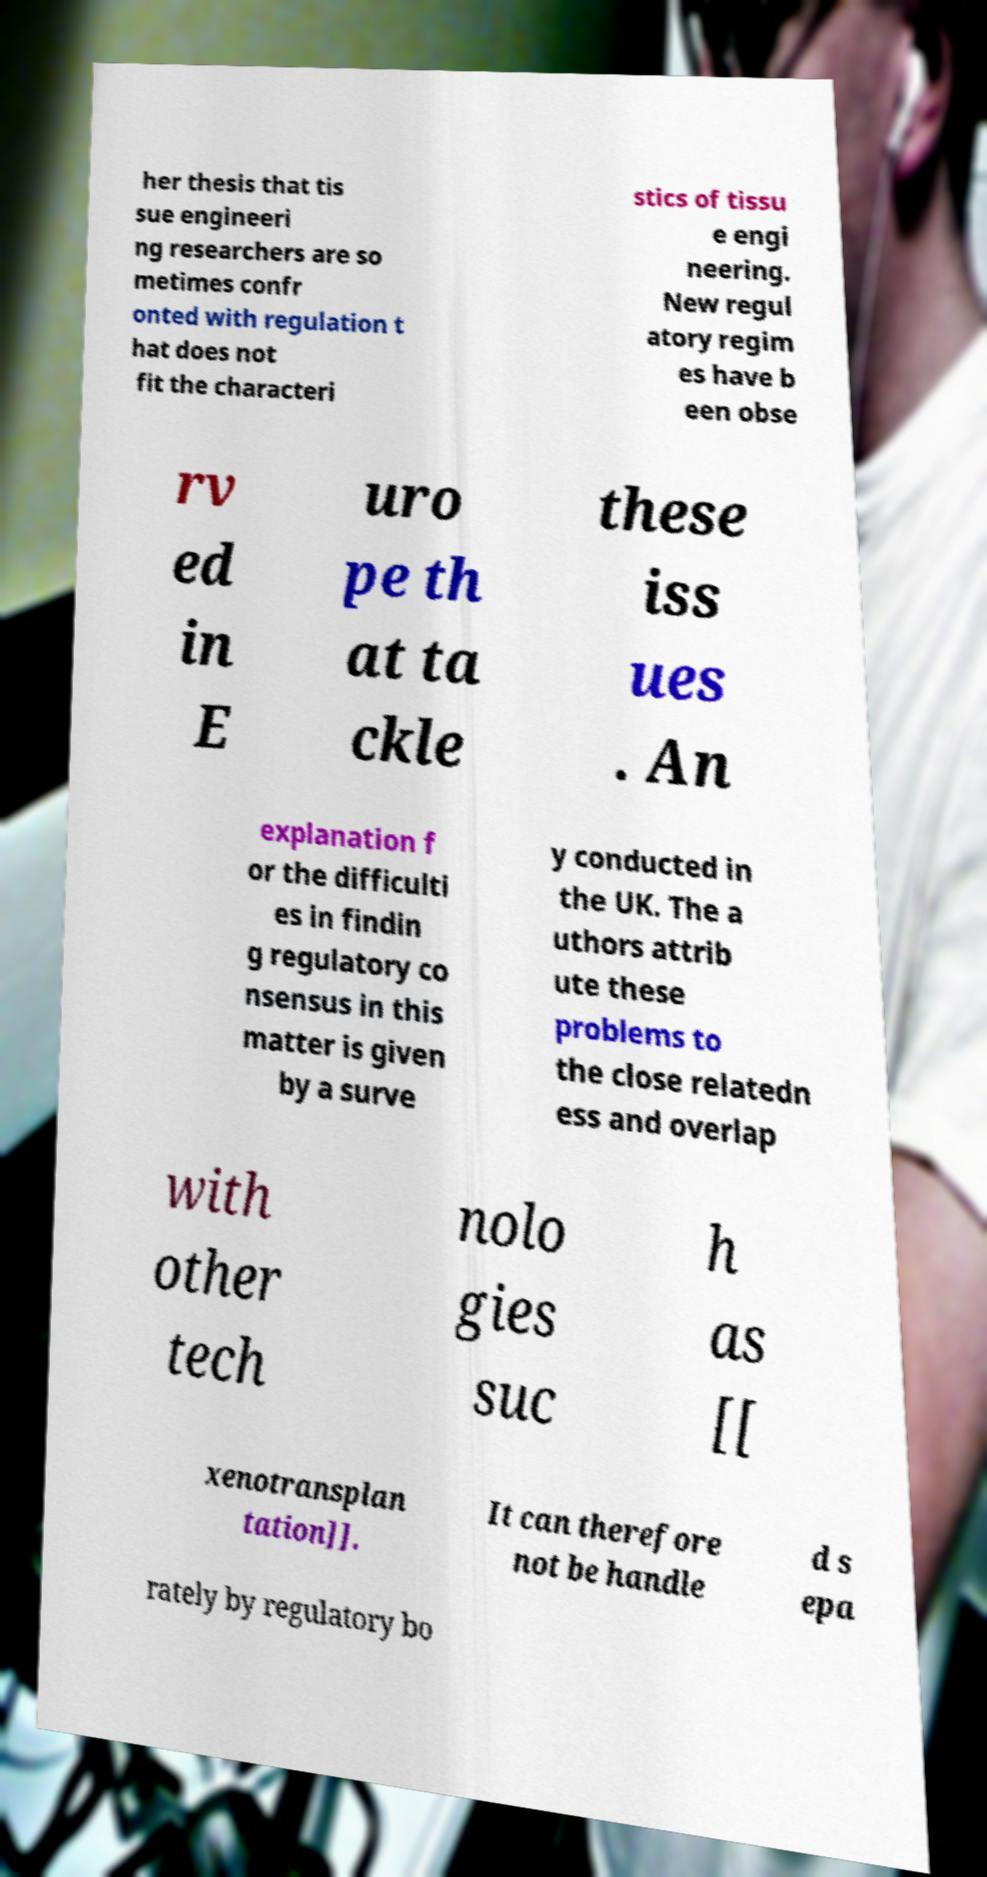I need the written content from this picture converted into text. Can you do that? her thesis that tis sue engineeri ng researchers are so metimes confr onted with regulation t hat does not fit the characteri stics of tissu e engi neering. New regul atory regim es have b een obse rv ed in E uro pe th at ta ckle these iss ues . An explanation f or the difficulti es in findin g regulatory co nsensus in this matter is given by a surve y conducted in the UK. The a uthors attrib ute these problems to the close relatedn ess and overlap with other tech nolo gies suc h as [[ xenotransplan tation]]. It can therefore not be handle d s epa rately by regulatory bo 